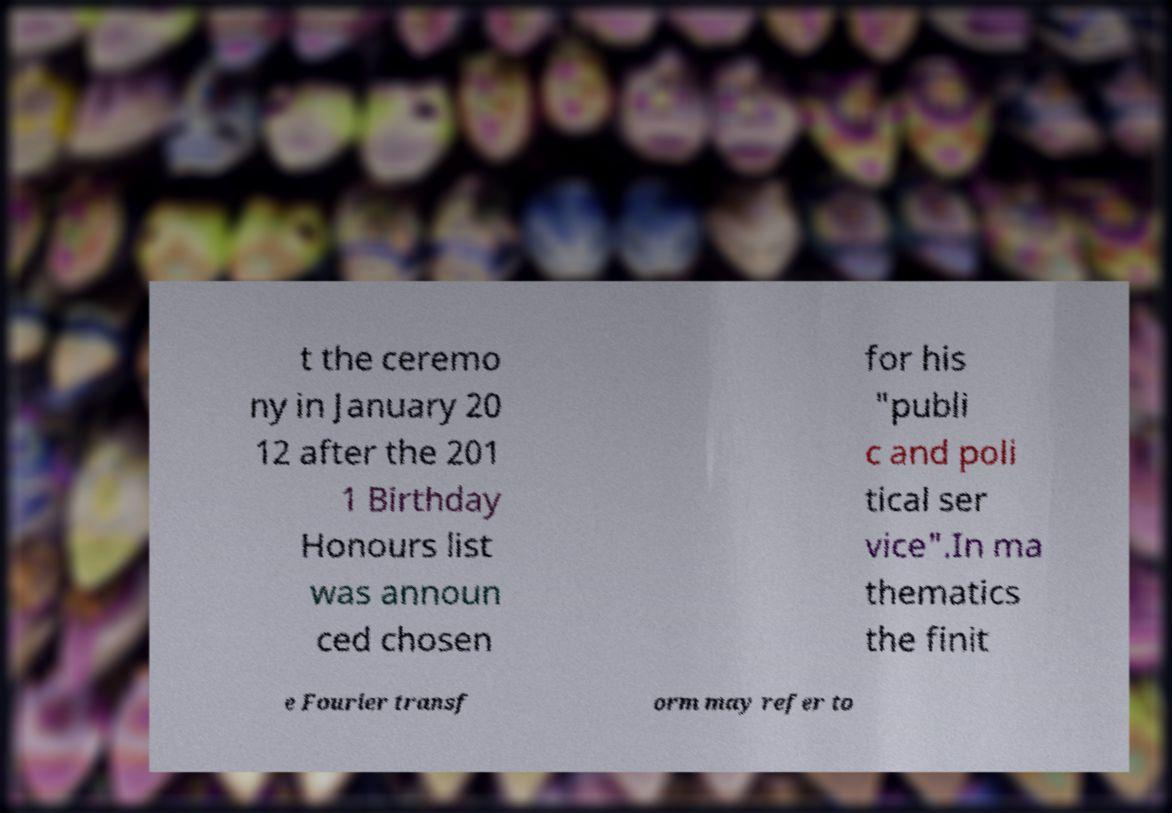Can you accurately transcribe the text from the provided image for me? t the ceremo ny in January 20 12 after the 201 1 Birthday Honours list was announ ced chosen for his "publi c and poli tical ser vice".In ma thematics the finit e Fourier transf orm may refer to 